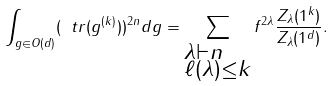Convert formula to latex. <formula><loc_0><loc_0><loc_500><loc_500>\int _ { g \in O ( d ) } ( \ t r ( g ^ { ( k ) } ) ) ^ { 2 n } d g = \sum _ { \begin{subarray} { c } \lambda \vdash n \\ \ell ( \lambda ) \leq k \end{subarray} } f ^ { 2 \lambda } \frac { Z _ { \lambda } ( 1 ^ { k } ) } { Z _ { \lambda } ( 1 ^ { d } ) } .</formula> 